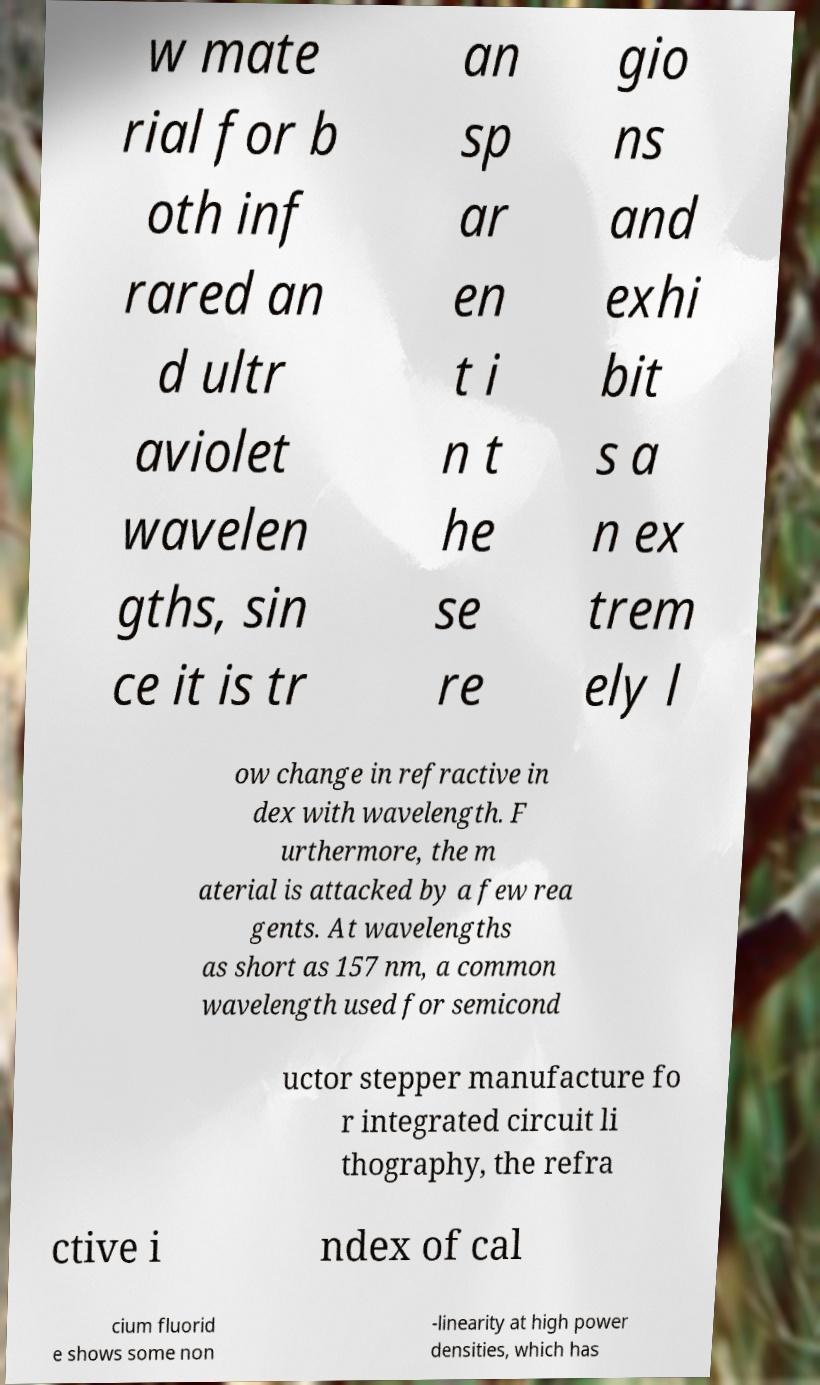For documentation purposes, I need the text within this image transcribed. Could you provide that? w mate rial for b oth inf rared an d ultr aviolet wavelen gths, sin ce it is tr an sp ar en t i n t he se re gio ns and exhi bit s a n ex trem ely l ow change in refractive in dex with wavelength. F urthermore, the m aterial is attacked by a few rea gents. At wavelengths as short as 157 nm, a common wavelength used for semicond uctor stepper manufacture fo r integrated circuit li thography, the refra ctive i ndex of cal cium fluorid e shows some non -linearity at high power densities, which has 